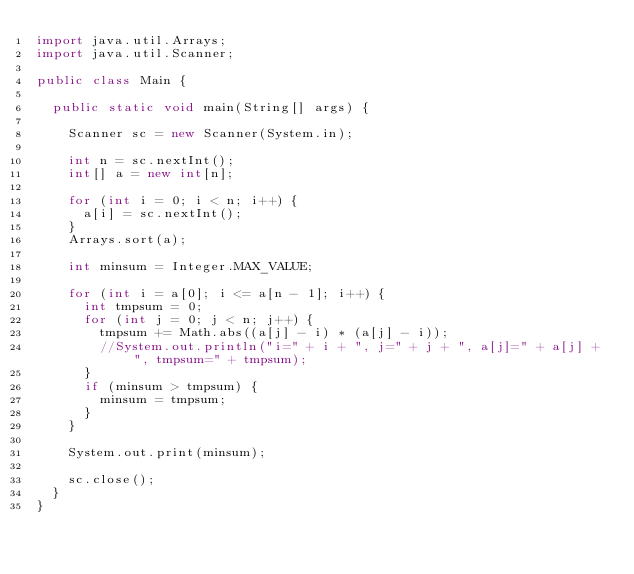<code> <loc_0><loc_0><loc_500><loc_500><_Java_>import java.util.Arrays;
import java.util.Scanner;

public class Main {

	public static void main(String[] args) {

		Scanner sc = new Scanner(System.in);

		int n = sc.nextInt();
		int[] a = new int[n];

		for (int i = 0; i < n; i++) {
			a[i] = sc.nextInt();
		}
		Arrays.sort(a);

		int minsum = Integer.MAX_VALUE;

		for (int i = a[0]; i <= a[n - 1]; i++) {
			int tmpsum = 0;
			for (int j = 0; j < n; j++) {
				tmpsum += Math.abs((a[j] - i) * (a[j] - i));
				//System.out.println("i=" + i + ", j=" + j + ", a[j]=" + a[j] + ", tmpsum=" + tmpsum);
			}
			if (minsum > tmpsum) {
				minsum = tmpsum;
			}
		}

		System.out.print(minsum);

		sc.close();
	}
}</code> 